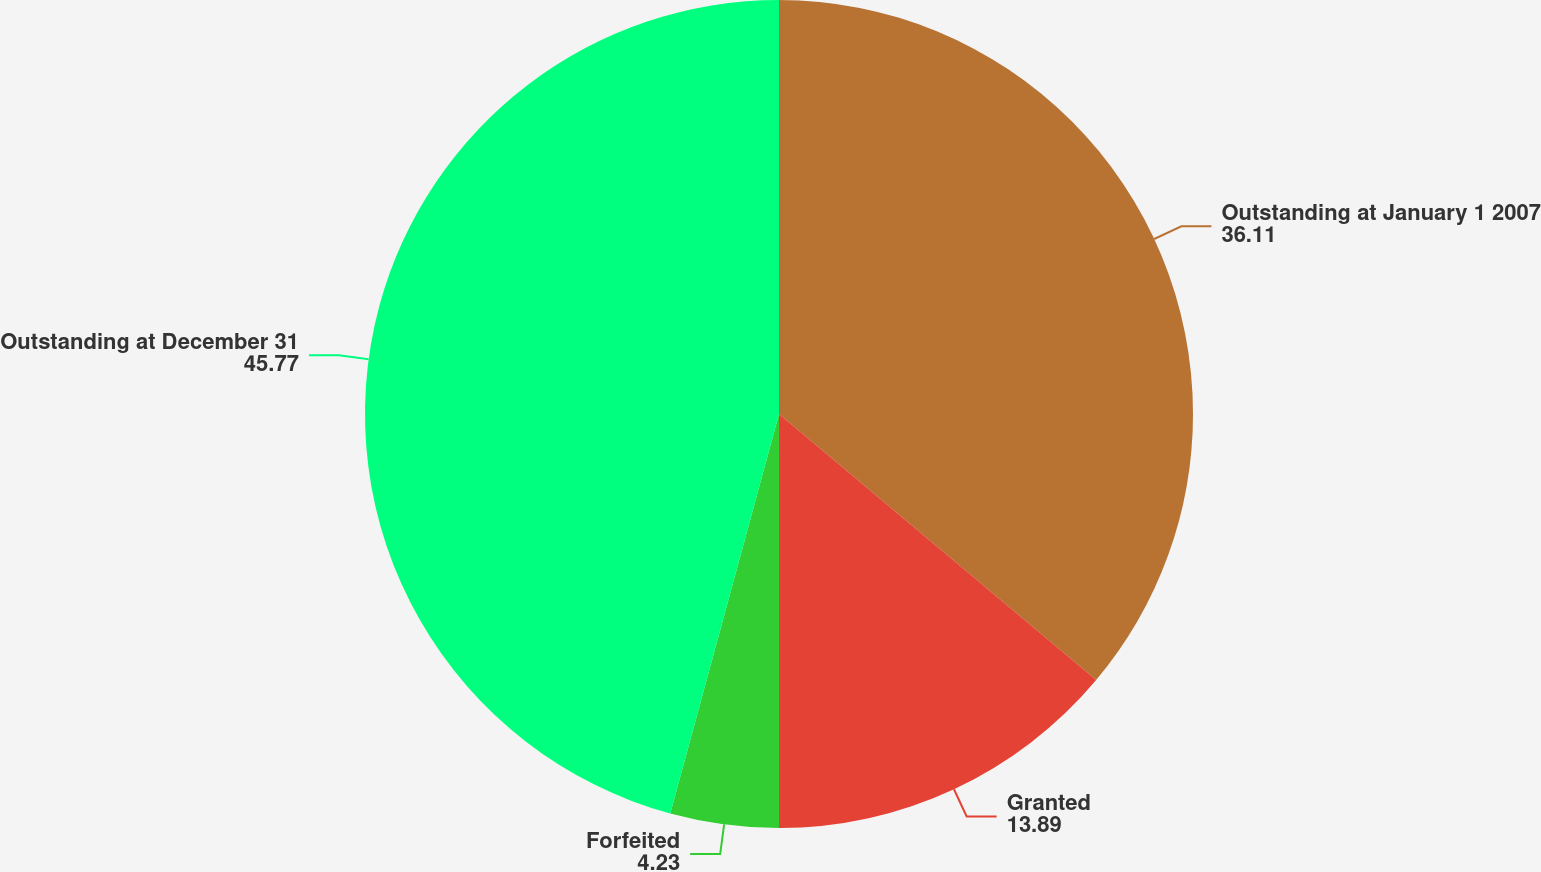Convert chart. <chart><loc_0><loc_0><loc_500><loc_500><pie_chart><fcel>Outstanding at January 1 2007<fcel>Granted<fcel>Forfeited<fcel>Outstanding at December 31<nl><fcel>36.11%<fcel>13.89%<fcel>4.23%<fcel>45.77%<nl></chart> 